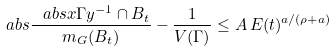<formula> <loc_0><loc_0><loc_500><loc_500>\ a b s { \frac { \ a b s { x \Gamma y ^ { - 1 } \cap B _ { t } } } { m _ { G } ( B _ { t } ) } - \frac { 1 } { V ( \Gamma ) } } \leq A \, E ( t ) ^ { a / ( \rho + a ) }</formula> 